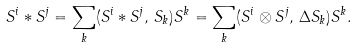<formula> <loc_0><loc_0><loc_500><loc_500>S ^ { i } * S ^ { j } = \sum _ { k } ( S ^ { i } * S ^ { j } , \, S _ { k } ) S ^ { k } = \sum _ { k } ( S ^ { i } \otimes S ^ { j } , \, \Delta S _ { k } ) S ^ { k } .</formula> 